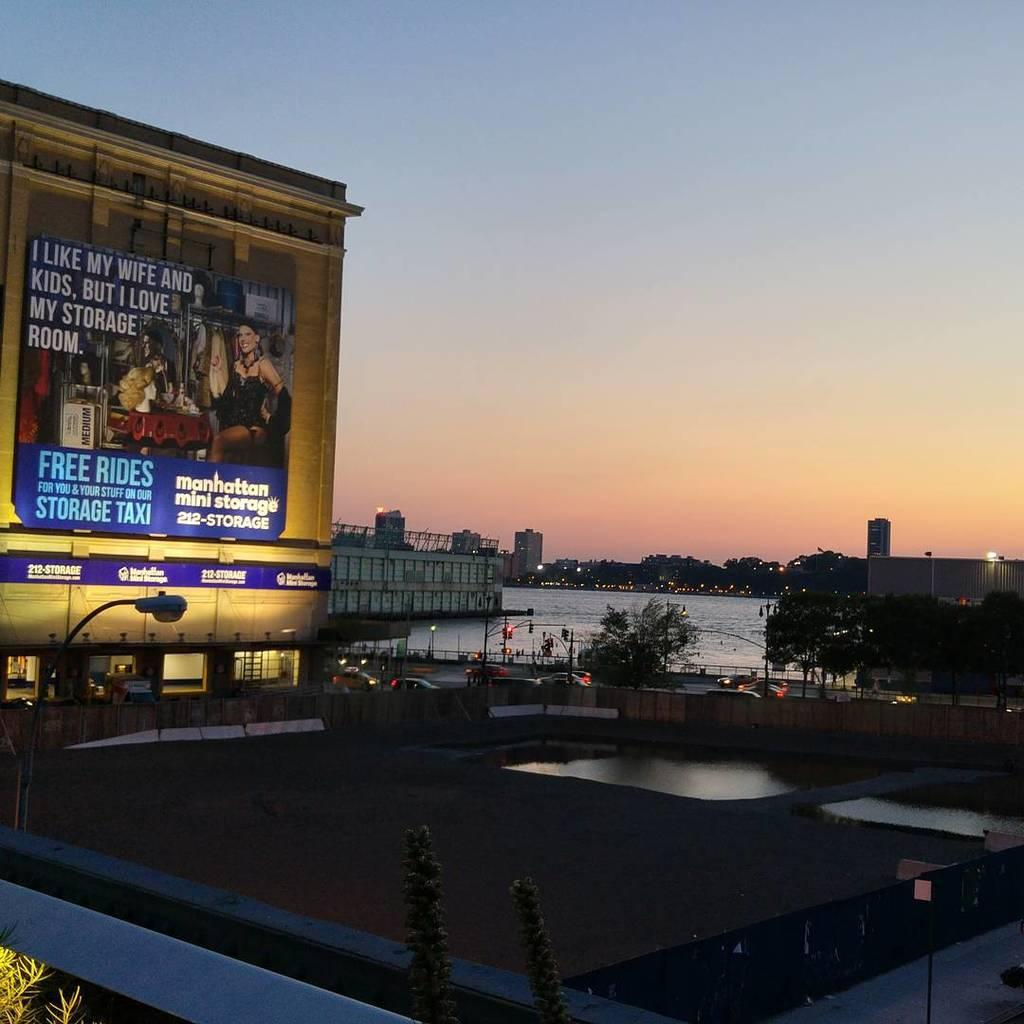<image>
Give a short and clear explanation of the subsequent image. the words free rides are on the sign outside 